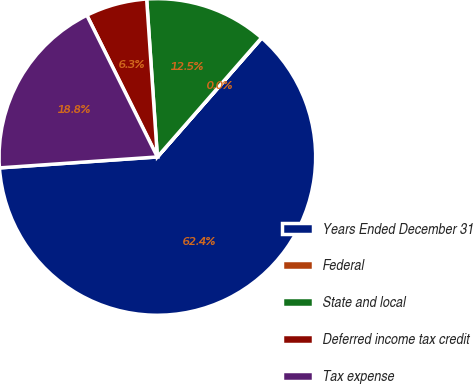Convert chart to OTSL. <chart><loc_0><loc_0><loc_500><loc_500><pie_chart><fcel>Years Ended December 31<fcel>Federal<fcel>State and local<fcel>Deferred income tax credit<fcel>Tax expense<nl><fcel>62.43%<fcel>0.03%<fcel>12.51%<fcel>6.27%<fcel>18.75%<nl></chart> 